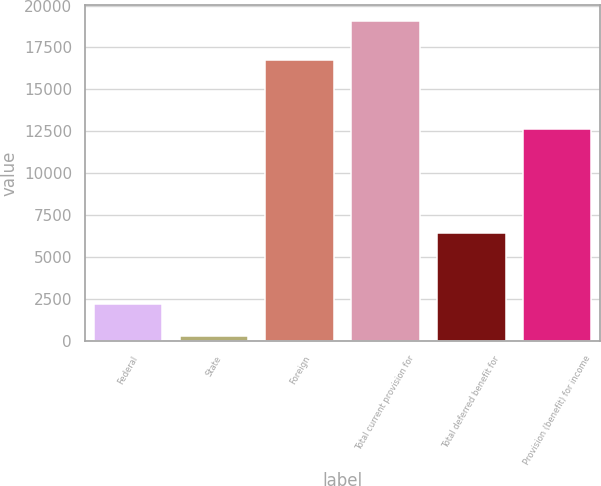Convert chart. <chart><loc_0><loc_0><loc_500><loc_500><bar_chart><fcel>Federal<fcel>State<fcel>Foreign<fcel>Total current provision for<fcel>Total deferred benefit for<fcel>Provision (benefit) for income<nl><fcel>2190.4<fcel>316<fcel>16767<fcel>19060<fcel>6415<fcel>12645<nl></chart> 